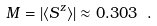<formula> <loc_0><loc_0><loc_500><loc_500>M = | \langle S ^ { z } \rangle | \approx 0 . 3 0 3 \ .</formula> 